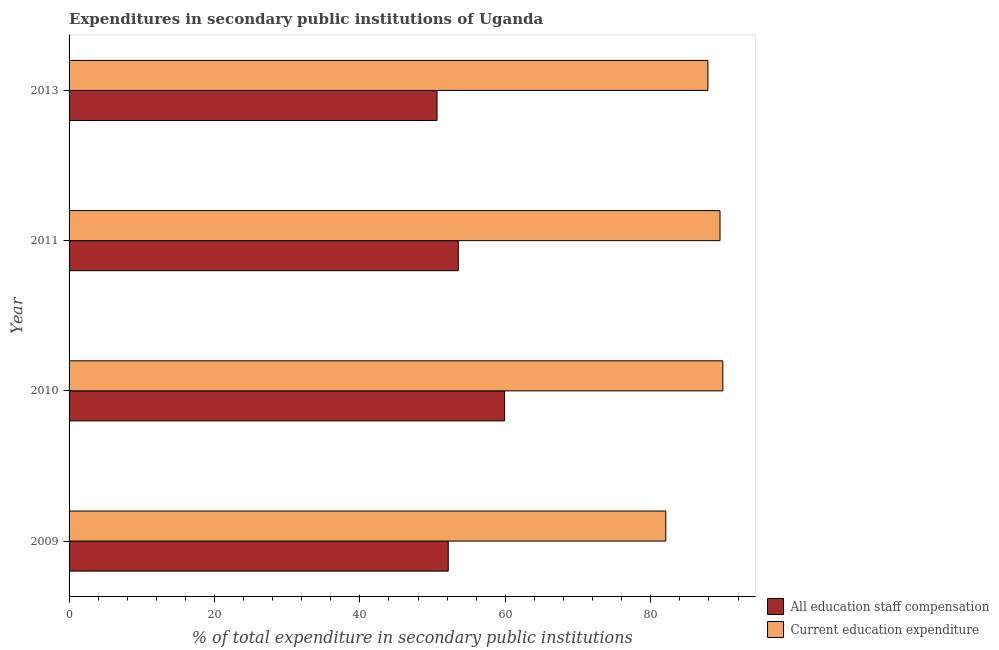How many groups of bars are there?
Give a very brief answer. 4. Are the number of bars per tick equal to the number of legend labels?
Keep it short and to the point. Yes. Are the number of bars on each tick of the Y-axis equal?
Make the answer very short. Yes. How many bars are there on the 3rd tick from the bottom?
Make the answer very short. 2. In how many cases, is the number of bars for a given year not equal to the number of legend labels?
Offer a very short reply. 0. What is the expenditure in staff compensation in 2009?
Give a very brief answer. 52.15. Across all years, what is the maximum expenditure in education?
Offer a very short reply. 89.91. Across all years, what is the minimum expenditure in education?
Give a very brief answer. 82.07. What is the total expenditure in education in the graph?
Give a very brief answer. 349.37. What is the difference between the expenditure in education in 2009 and that in 2010?
Your response must be concise. -7.85. What is the difference between the expenditure in staff compensation in 2010 and the expenditure in education in 2013?
Your response must be concise. -27.96. What is the average expenditure in education per year?
Ensure brevity in your answer.  87.34. In the year 2010, what is the difference between the expenditure in education and expenditure in staff compensation?
Your response must be concise. 30.02. In how many years, is the expenditure in staff compensation greater than 80 %?
Keep it short and to the point. 0. What is the ratio of the expenditure in education in 2009 to that in 2013?
Give a very brief answer. 0.93. What is the difference between the highest and the second highest expenditure in staff compensation?
Make the answer very short. 6.37. What is the difference between the highest and the lowest expenditure in education?
Ensure brevity in your answer.  7.85. In how many years, is the expenditure in education greater than the average expenditure in education taken over all years?
Keep it short and to the point. 3. Is the sum of the expenditure in staff compensation in 2009 and 2011 greater than the maximum expenditure in education across all years?
Your response must be concise. Yes. What does the 1st bar from the top in 2011 represents?
Provide a succinct answer. Current education expenditure. What does the 2nd bar from the bottom in 2011 represents?
Provide a succinct answer. Current education expenditure. Are all the bars in the graph horizontal?
Your response must be concise. Yes. How many years are there in the graph?
Offer a very short reply. 4. Are the values on the major ticks of X-axis written in scientific E-notation?
Your answer should be very brief. No. Does the graph contain grids?
Your response must be concise. No. How many legend labels are there?
Your answer should be very brief. 2. What is the title of the graph?
Your response must be concise. Expenditures in secondary public institutions of Uganda. Does "Automatic Teller Machines" appear as one of the legend labels in the graph?
Offer a terse response. No. What is the label or title of the X-axis?
Offer a very short reply. % of total expenditure in secondary public institutions. What is the % of total expenditure in secondary public institutions of All education staff compensation in 2009?
Ensure brevity in your answer.  52.15. What is the % of total expenditure in secondary public institutions in Current education expenditure in 2009?
Offer a very short reply. 82.07. What is the % of total expenditure in secondary public institutions of All education staff compensation in 2010?
Your response must be concise. 59.9. What is the % of total expenditure in secondary public institutions of Current education expenditure in 2010?
Your answer should be compact. 89.91. What is the % of total expenditure in secondary public institutions in All education staff compensation in 2011?
Keep it short and to the point. 53.53. What is the % of total expenditure in secondary public institutions of Current education expenditure in 2011?
Keep it short and to the point. 89.53. What is the % of total expenditure in secondary public institutions of All education staff compensation in 2013?
Ensure brevity in your answer.  50.6. What is the % of total expenditure in secondary public institutions of Current education expenditure in 2013?
Your answer should be compact. 87.86. Across all years, what is the maximum % of total expenditure in secondary public institutions in All education staff compensation?
Provide a short and direct response. 59.9. Across all years, what is the maximum % of total expenditure in secondary public institutions in Current education expenditure?
Provide a succinct answer. 89.91. Across all years, what is the minimum % of total expenditure in secondary public institutions of All education staff compensation?
Your answer should be compact. 50.6. Across all years, what is the minimum % of total expenditure in secondary public institutions in Current education expenditure?
Give a very brief answer. 82.07. What is the total % of total expenditure in secondary public institutions of All education staff compensation in the graph?
Your answer should be very brief. 216.18. What is the total % of total expenditure in secondary public institutions of Current education expenditure in the graph?
Your answer should be compact. 349.37. What is the difference between the % of total expenditure in secondary public institutions in All education staff compensation in 2009 and that in 2010?
Give a very brief answer. -7.75. What is the difference between the % of total expenditure in secondary public institutions of Current education expenditure in 2009 and that in 2010?
Keep it short and to the point. -7.85. What is the difference between the % of total expenditure in secondary public institutions in All education staff compensation in 2009 and that in 2011?
Your answer should be compact. -1.38. What is the difference between the % of total expenditure in secondary public institutions of Current education expenditure in 2009 and that in 2011?
Provide a short and direct response. -7.46. What is the difference between the % of total expenditure in secondary public institutions of All education staff compensation in 2009 and that in 2013?
Your response must be concise. 1.55. What is the difference between the % of total expenditure in secondary public institutions in Current education expenditure in 2009 and that in 2013?
Ensure brevity in your answer.  -5.79. What is the difference between the % of total expenditure in secondary public institutions in All education staff compensation in 2010 and that in 2011?
Make the answer very short. 6.36. What is the difference between the % of total expenditure in secondary public institutions in Current education expenditure in 2010 and that in 2011?
Give a very brief answer. 0.39. What is the difference between the % of total expenditure in secondary public institutions in All education staff compensation in 2010 and that in 2013?
Your answer should be compact. 9.29. What is the difference between the % of total expenditure in secondary public institutions of Current education expenditure in 2010 and that in 2013?
Your answer should be very brief. 2.05. What is the difference between the % of total expenditure in secondary public institutions in All education staff compensation in 2011 and that in 2013?
Make the answer very short. 2.93. What is the difference between the % of total expenditure in secondary public institutions in Current education expenditure in 2011 and that in 2013?
Offer a very short reply. 1.67. What is the difference between the % of total expenditure in secondary public institutions of All education staff compensation in 2009 and the % of total expenditure in secondary public institutions of Current education expenditure in 2010?
Ensure brevity in your answer.  -37.76. What is the difference between the % of total expenditure in secondary public institutions of All education staff compensation in 2009 and the % of total expenditure in secondary public institutions of Current education expenditure in 2011?
Give a very brief answer. -37.38. What is the difference between the % of total expenditure in secondary public institutions of All education staff compensation in 2009 and the % of total expenditure in secondary public institutions of Current education expenditure in 2013?
Make the answer very short. -35.71. What is the difference between the % of total expenditure in secondary public institutions in All education staff compensation in 2010 and the % of total expenditure in secondary public institutions in Current education expenditure in 2011?
Give a very brief answer. -29.63. What is the difference between the % of total expenditure in secondary public institutions of All education staff compensation in 2010 and the % of total expenditure in secondary public institutions of Current education expenditure in 2013?
Provide a short and direct response. -27.96. What is the difference between the % of total expenditure in secondary public institutions in All education staff compensation in 2011 and the % of total expenditure in secondary public institutions in Current education expenditure in 2013?
Offer a terse response. -34.33. What is the average % of total expenditure in secondary public institutions in All education staff compensation per year?
Your response must be concise. 54.05. What is the average % of total expenditure in secondary public institutions of Current education expenditure per year?
Your answer should be very brief. 87.34. In the year 2009, what is the difference between the % of total expenditure in secondary public institutions of All education staff compensation and % of total expenditure in secondary public institutions of Current education expenditure?
Your answer should be compact. -29.92. In the year 2010, what is the difference between the % of total expenditure in secondary public institutions of All education staff compensation and % of total expenditure in secondary public institutions of Current education expenditure?
Your response must be concise. -30.02. In the year 2011, what is the difference between the % of total expenditure in secondary public institutions of All education staff compensation and % of total expenditure in secondary public institutions of Current education expenditure?
Give a very brief answer. -36. In the year 2013, what is the difference between the % of total expenditure in secondary public institutions of All education staff compensation and % of total expenditure in secondary public institutions of Current education expenditure?
Give a very brief answer. -37.26. What is the ratio of the % of total expenditure in secondary public institutions of All education staff compensation in 2009 to that in 2010?
Make the answer very short. 0.87. What is the ratio of the % of total expenditure in secondary public institutions of Current education expenditure in 2009 to that in 2010?
Your response must be concise. 0.91. What is the ratio of the % of total expenditure in secondary public institutions of All education staff compensation in 2009 to that in 2011?
Your response must be concise. 0.97. What is the ratio of the % of total expenditure in secondary public institutions in Current education expenditure in 2009 to that in 2011?
Make the answer very short. 0.92. What is the ratio of the % of total expenditure in secondary public institutions of All education staff compensation in 2009 to that in 2013?
Provide a succinct answer. 1.03. What is the ratio of the % of total expenditure in secondary public institutions of Current education expenditure in 2009 to that in 2013?
Keep it short and to the point. 0.93. What is the ratio of the % of total expenditure in secondary public institutions in All education staff compensation in 2010 to that in 2011?
Offer a very short reply. 1.12. What is the ratio of the % of total expenditure in secondary public institutions in All education staff compensation in 2010 to that in 2013?
Offer a terse response. 1.18. What is the ratio of the % of total expenditure in secondary public institutions in Current education expenditure in 2010 to that in 2013?
Keep it short and to the point. 1.02. What is the ratio of the % of total expenditure in secondary public institutions of All education staff compensation in 2011 to that in 2013?
Provide a succinct answer. 1.06. What is the difference between the highest and the second highest % of total expenditure in secondary public institutions of All education staff compensation?
Offer a very short reply. 6.36. What is the difference between the highest and the second highest % of total expenditure in secondary public institutions in Current education expenditure?
Your response must be concise. 0.39. What is the difference between the highest and the lowest % of total expenditure in secondary public institutions of All education staff compensation?
Offer a very short reply. 9.29. What is the difference between the highest and the lowest % of total expenditure in secondary public institutions in Current education expenditure?
Keep it short and to the point. 7.85. 